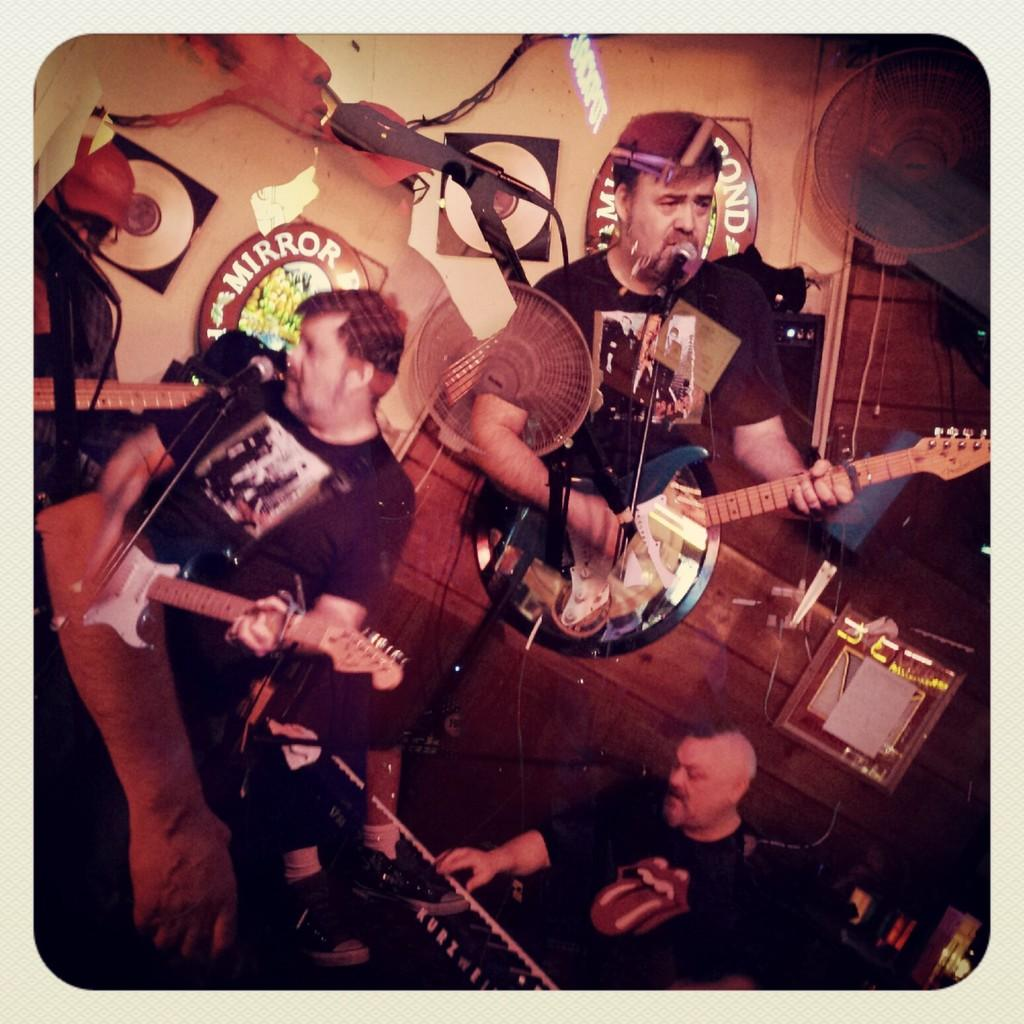What is the person in the image doing? The person is holding a guitar. What object is in the middle of the image? There is a microphone in the middle of the image. What can be seen on the wall in the image? There are symbols on the wall. What part of the room is visible in the image? The wall is visible at the top of the image. Can you see the band jumping on the hill in the image? There is no band or hill present in the image; it features a person holding a guitar, a microphone, and symbols on the wall. 